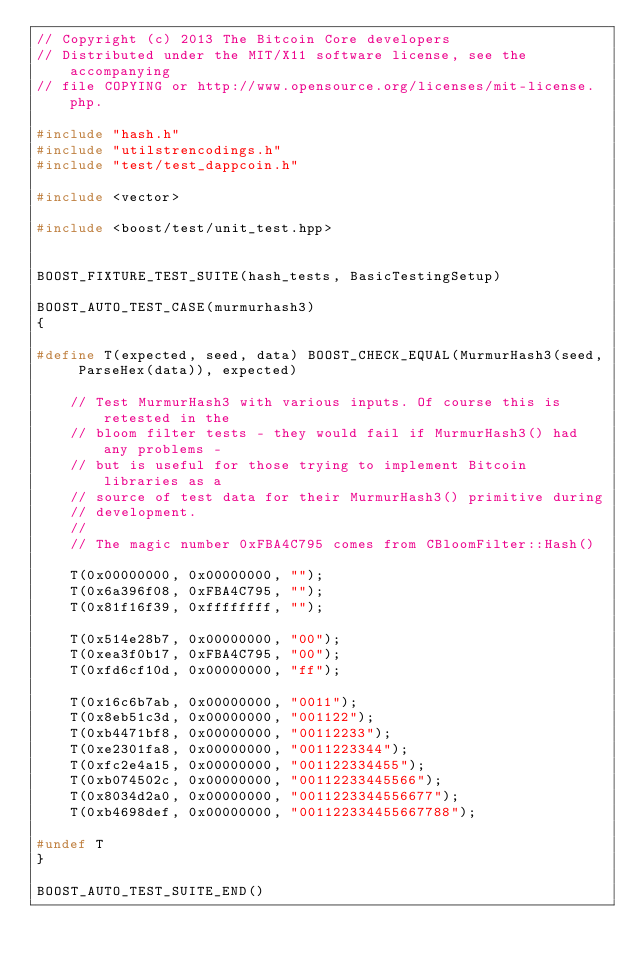Convert code to text. <code><loc_0><loc_0><loc_500><loc_500><_C++_>// Copyright (c) 2013 The Bitcoin Core developers
// Distributed under the MIT/X11 software license, see the accompanying
// file COPYING or http://www.opensource.org/licenses/mit-license.php.

#include "hash.h"
#include "utilstrencodings.h"
#include "test/test_dappcoin.h"

#include <vector>

#include <boost/test/unit_test.hpp>


BOOST_FIXTURE_TEST_SUITE(hash_tests, BasicTestingSetup)

BOOST_AUTO_TEST_CASE(murmurhash3)
{

#define T(expected, seed, data) BOOST_CHECK_EQUAL(MurmurHash3(seed, ParseHex(data)), expected)

    // Test MurmurHash3 with various inputs. Of course this is retested in the
    // bloom filter tests - they would fail if MurmurHash3() had any problems -
    // but is useful for those trying to implement Bitcoin libraries as a
    // source of test data for their MurmurHash3() primitive during
    // development.
    //
    // The magic number 0xFBA4C795 comes from CBloomFilter::Hash()

    T(0x00000000, 0x00000000, "");
    T(0x6a396f08, 0xFBA4C795, "");
    T(0x81f16f39, 0xffffffff, "");

    T(0x514e28b7, 0x00000000, "00");
    T(0xea3f0b17, 0xFBA4C795, "00");
    T(0xfd6cf10d, 0x00000000, "ff");

    T(0x16c6b7ab, 0x00000000, "0011");
    T(0x8eb51c3d, 0x00000000, "001122");
    T(0xb4471bf8, 0x00000000, "00112233");
    T(0xe2301fa8, 0x00000000, "0011223344");
    T(0xfc2e4a15, 0x00000000, "001122334455");
    T(0xb074502c, 0x00000000, "00112233445566");
    T(0x8034d2a0, 0x00000000, "0011223344556677");
    T(0xb4698def, 0x00000000, "001122334455667788");

#undef T
}

BOOST_AUTO_TEST_SUITE_END()
</code> 